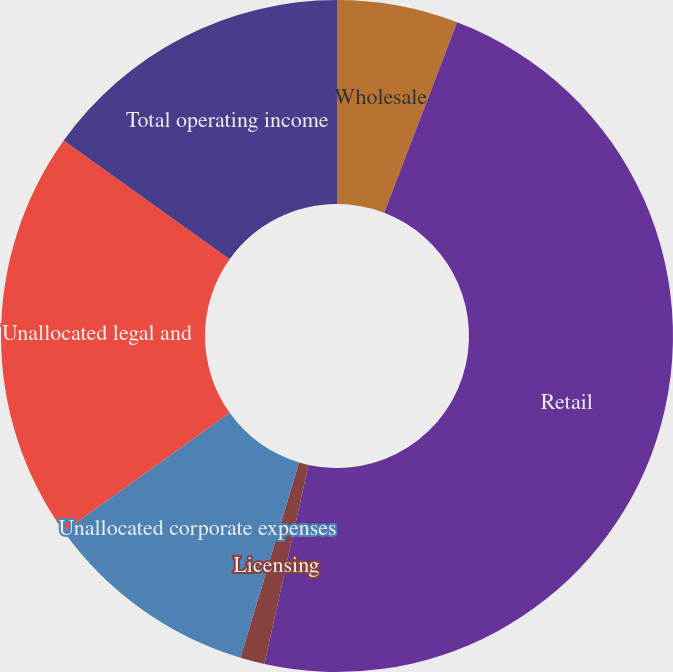Convert chart. <chart><loc_0><loc_0><loc_500><loc_500><pie_chart><fcel>Wholesale<fcel>Retail<fcel>Licensing<fcel>Unallocated corporate expenses<fcel>Unallocated legal and<fcel>Total operating income<nl><fcel>5.82%<fcel>47.65%<fcel>1.17%<fcel>10.47%<fcel>19.77%<fcel>15.12%<nl></chart> 